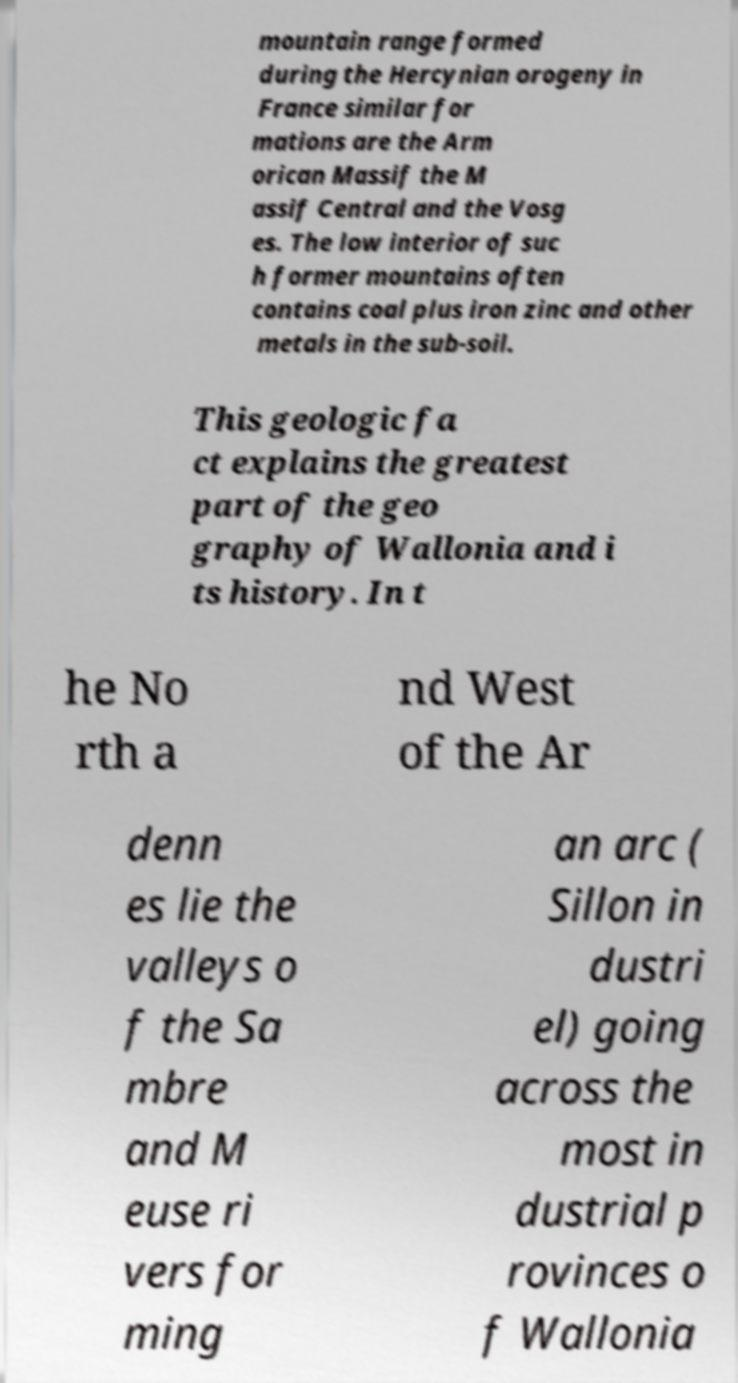I need the written content from this picture converted into text. Can you do that? mountain range formed during the Hercynian orogeny in France similar for mations are the Arm orican Massif the M assif Central and the Vosg es. The low interior of suc h former mountains often contains coal plus iron zinc and other metals in the sub-soil. This geologic fa ct explains the greatest part of the geo graphy of Wallonia and i ts history. In t he No rth a nd West of the Ar denn es lie the valleys o f the Sa mbre and M euse ri vers for ming an arc ( Sillon in dustri el) going across the most in dustrial p rovinces o f Wallonia 